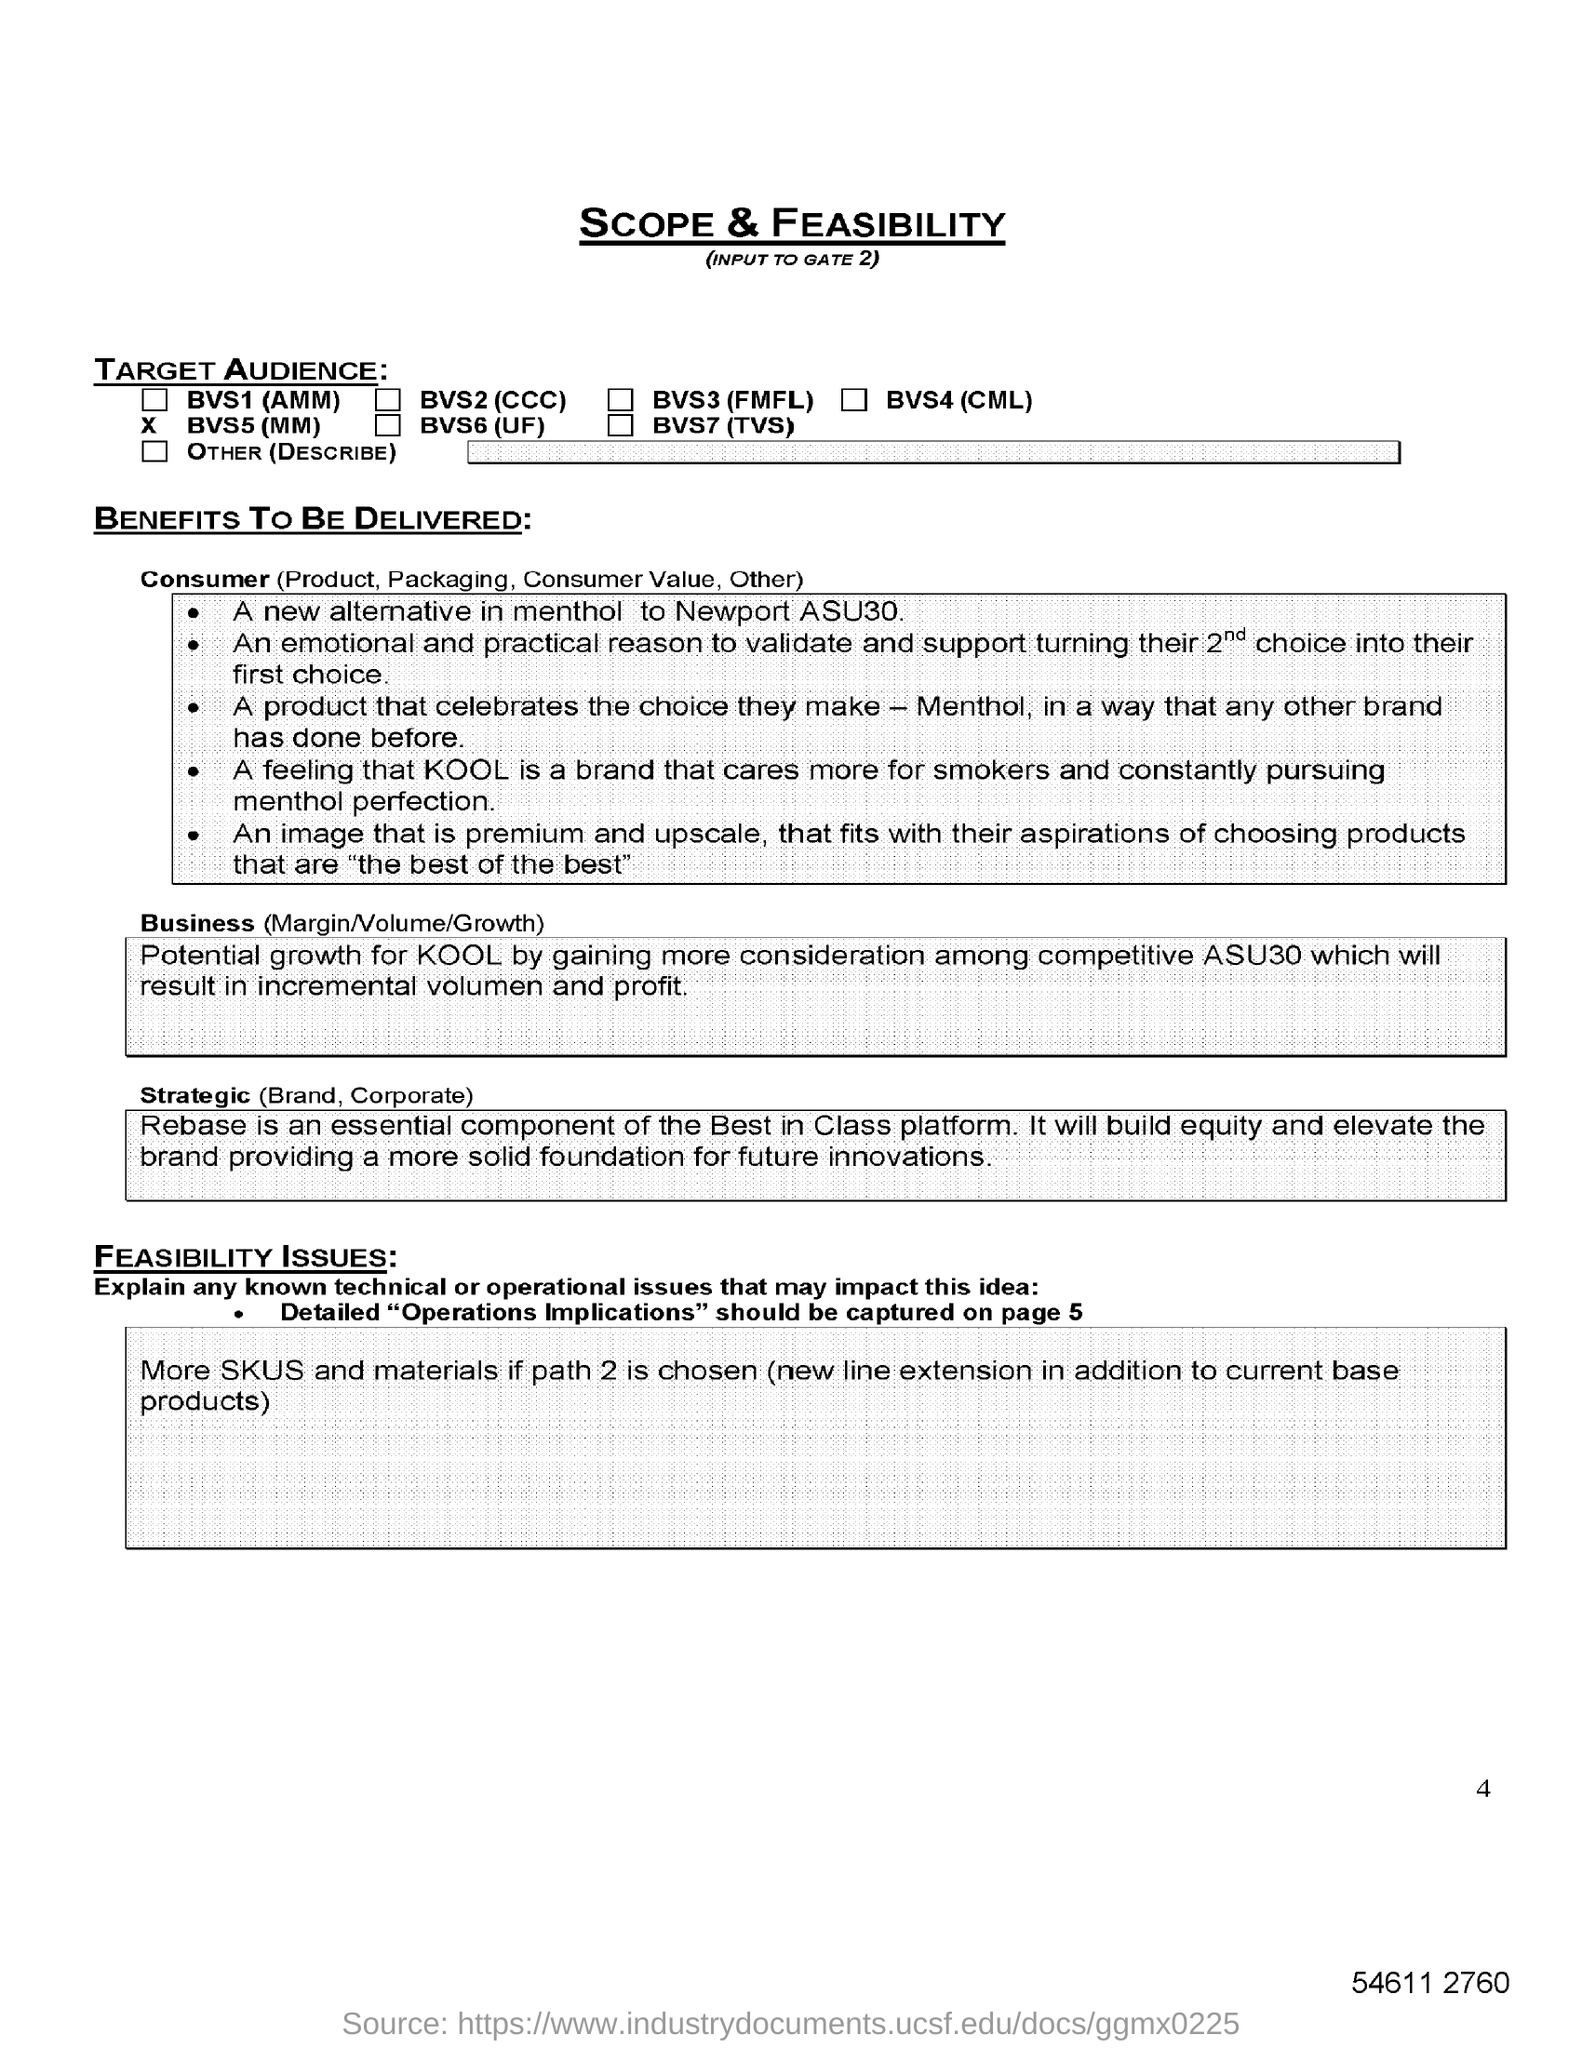What is the heading of the document?
Your answer should be compact. SCOPE & FEASIBILITY. What does the brand KOOL cares more for?
Offer a very short reply. Smokers and constantly pursuing menthol perfection. What is the alternative in menthol?
Keep it short and to the point. Newport ASU30. What is the first TARGET AUDIENCE mentioned?
Keep it short and to the point. BVS1 (AMM). 